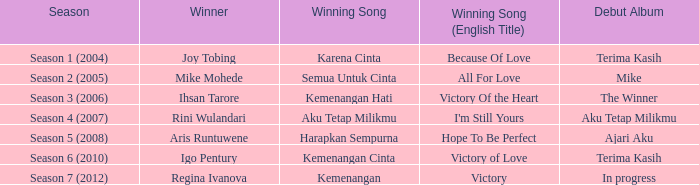Which successful song had an initial album in progress? Kemenangan. Give me the full table as a dictionary. {'header': ['Season', 'Winner', 'Winning Song', 'Winning Song (English Title)', 'Debut Album'], 'rows': [['Season 1 (2004)', 'Joy Tobing', 'Karena Cinta', 'Because Of Love', 'Terima Kasih'], ['Season 2 (2005)', 'Mike Mohede', 'Semua Untuk Cinta', 'All For Love', 'Mike'], ['Season 3 (2006)', 'Ihsan Tarore', 'Kemenangan Hati', 'Victory Of the Heart', 'The Winner'], ['Season 4 (2007)', 'Rini Wulandari', 'Aku Tetap Milikmu', "I'm Still Yours", 'Aku Tetap Milikmu'], ['Season 5 (2008)', 'Aris Runtuwene', 'Harapkan Sempurna', 'Hope To Be Perfect', 'Ajari Aku'], ['Season 6 (2010)', 'Igo Pentury', 'Kemenangan Cinta', 'Victory of Love', 'Terima Kasih'], ['Season 7 (2012)', 'Regina Ivanova', 'Kemenangan', 'Victory', 'In progress']]} 